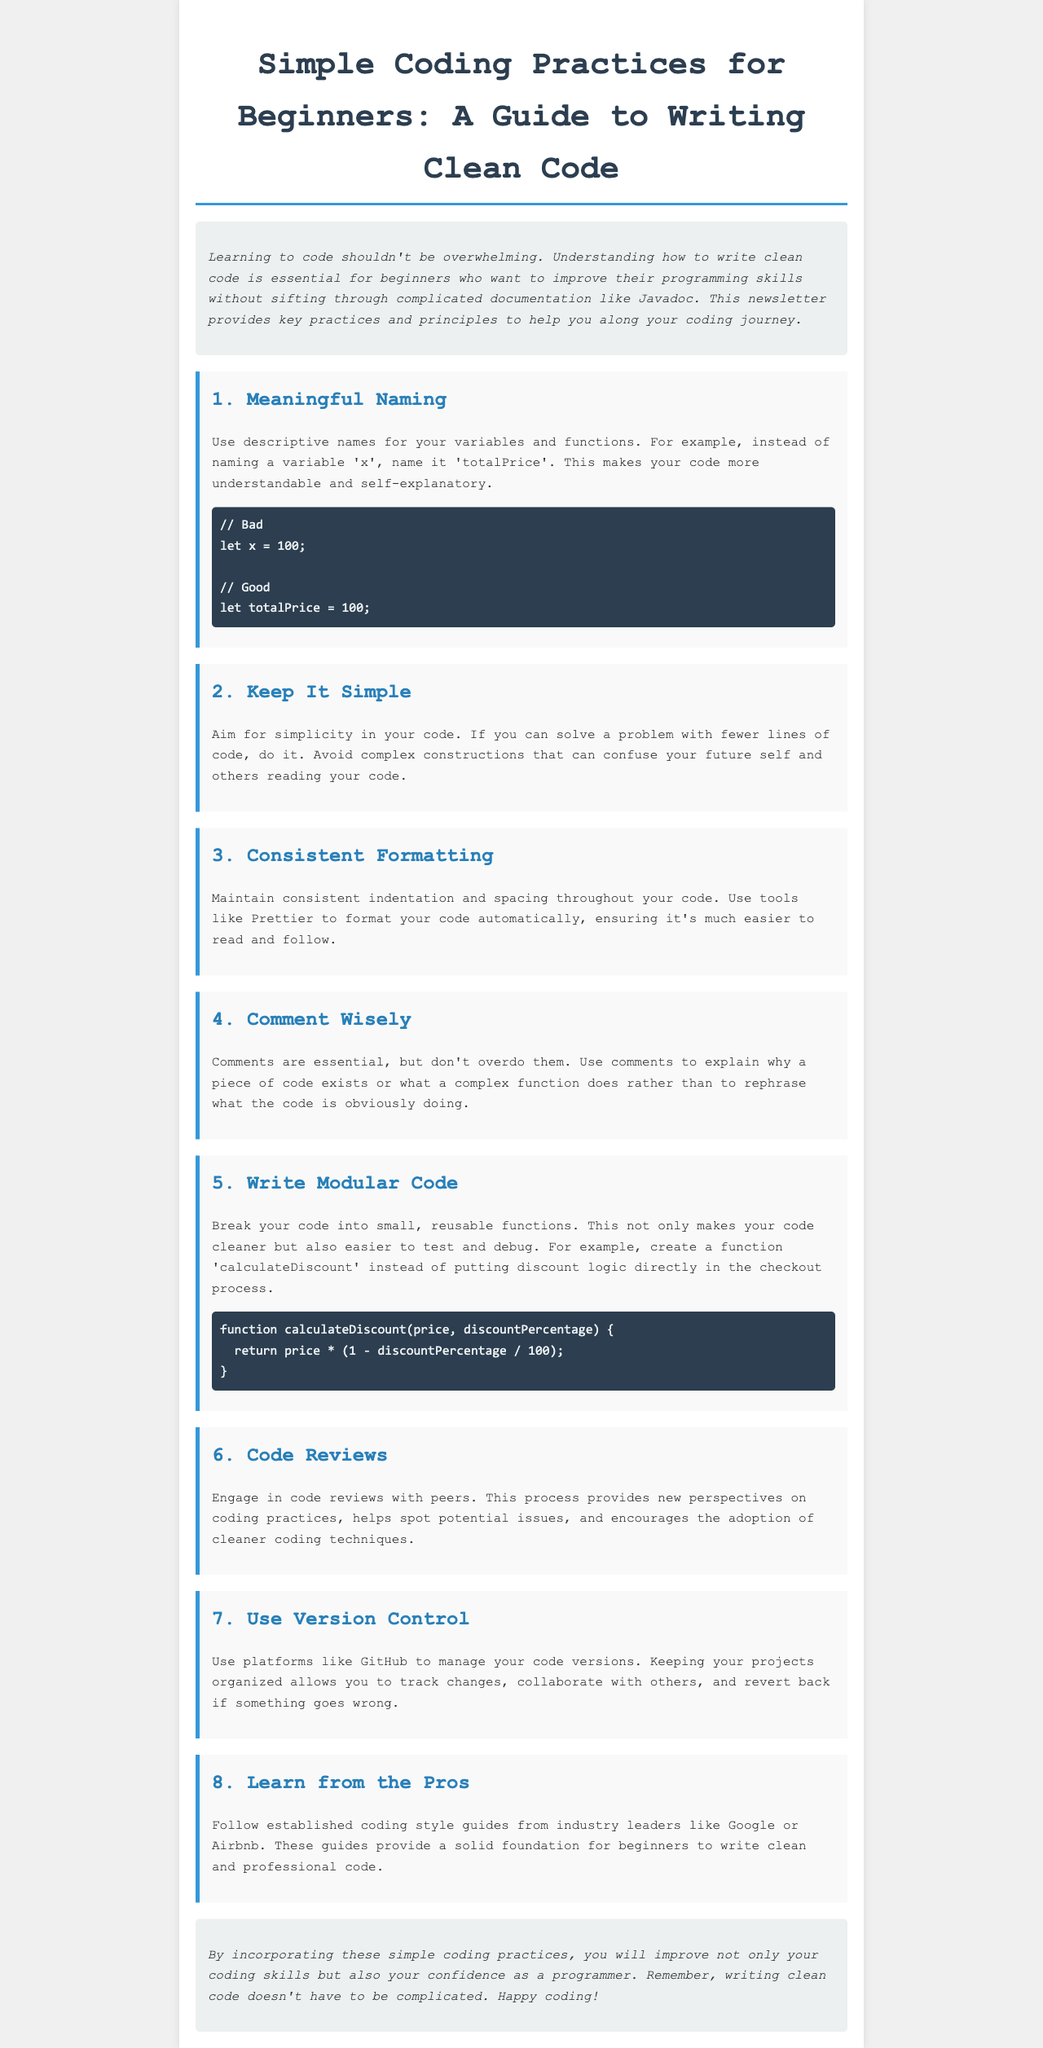What is the title of the newsletter? The title of the newsletter is prominently displayed at the top of the document, indicating the main topic.
Answer: Simple Coding Practices for Beginners: A Guide to Writing Clean Code What is one key practice for naming variables? This information is found in the first section of the newsletter, emphasizing the importance of meaningful names.
Answer: Meaningful Naming How many main practices are listed in the newsletter? The number of practices can be found by counting the section headers, which are numbered sequentially.
Answer: Eight What should you keep in mind while writing comments? The newsletter advises on the proper use of comments, emphasizing quality over quantity.
Answer: Comment Wisely What coding tool is suggested for consistent formatting? This specific piece of information can be found in the section discussing formatting practices.
Answer: Prettier Why is it important to engage in code reviews? The newsletter explains the purpose and benefits of code reviews in enhancing coding practices.
Answer: New perspectives Which function example is provided for modular coding? The newsletter contains a specific example of a function that illustrates the concept of modular coding.
Answer: calculateDiscount What is a recommended platform for version control? This information is provided in the section discussing version control practices and tools.
Answer: GitHub What is emphasized in the conclusion of the newsletter? The conclusion summarizes the overall message of the newsletter about coding practices.
Answer: Improve coding skills 